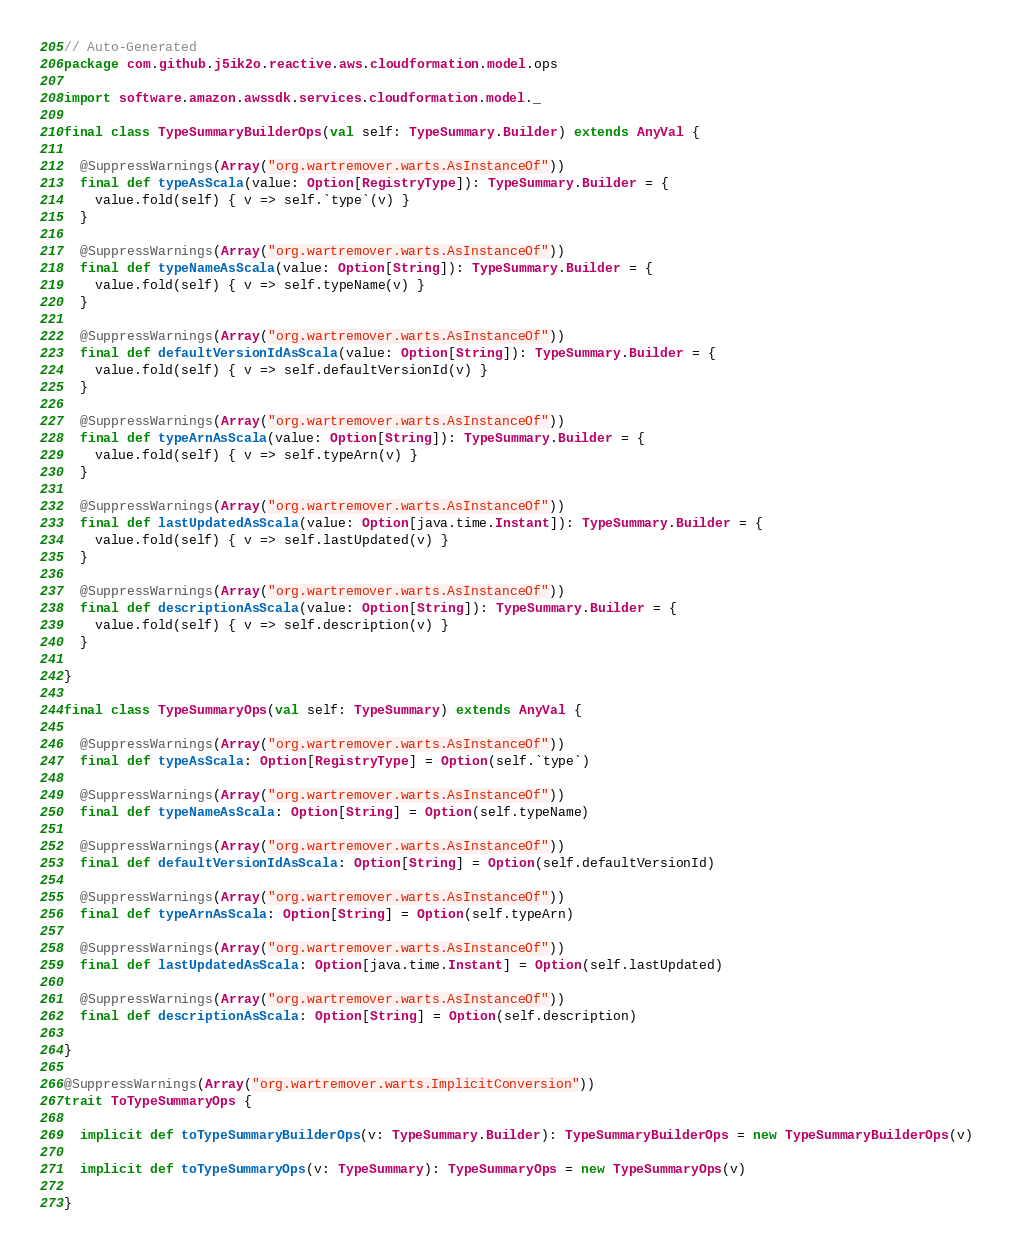Convert code to text. <code><loc_0><loc_0><loc_500><loc_500><_Scala_>// Auto-Generated
package com.github.j5ik2o.reactive.aws.cloudformation.model.ops

import software.amazon.awssdk.services.cloudformation.model._

final class TypeSummaryBuilderOps(val self: TypeSummary.Builder) extends AnyVal {

  @SuppressWarnings(Array("org.wartremover.warts.AsInstanceOf"))
  final def typeAsScala(value: Option[RegistryType]): TypeSummary.Builder = {
    value.fold(self) { v => self.`type`(v) }
  }

  @SuppressWarnings(Array("org.wartremover.warts.AsInstanceOf"))
  final def typeNameAsScala(value: Option[String]): TypeSummary.Builder = {
    value.fold(self) { v => self.typeName(v) }
  }

  @SuppressWarnings(Array("org.wartremover.warts.AsInstanceOf"))
  final def defaultVersionIdAsScala(value: Option[String]): TypeSummary.Builder = {
    value.fold(self) { v => self.defaultVersionId(v) }
  }

  @SuppressWarnings(Array("org.wartremover.warts.AsInstanceOf"))
  final def typeArnAsScala(value: Option[String]): TypeSummary.Builder = {
    value.fold(self) { v => self.typeArn(v) }
  }

  @SuppressWarnings(Array("org.wartremover.warts.AsInstanceOf"))
  final def lastUpdatedAsScala(value: Option[java.time.Instant]): TypeSummary.Builder = {
    value.fold(self) { v => self.lastUpdated(v) }
  }

  @SuppressWarnings(Array("org.wartremover.warts.AsInstanceOf"))
  final def descriptionAsScala(value: Option[String]): TypeSummary.Builder = {
    value.fold(self) { v => self.description(v) }
  }

}

final class TypeSummaryOps(val self: TypeSummary) extends AnyVal {

  @SuppressWarnings(Array("org.wartremover.warts.AsInstanceOf"))
  final def typeAsScala: Option[RegistryType] = Option(self.`type`)

  @SuppressWarnings(Array("org.wartremover.warts.AsInstanceOf"))
  final def typeNameAsScala: Option[String] = Option(self.typeName)

  @SuppressWarnings(Array("org.wartremover.warts.AsInstanceOf"))
  final def defaultVersionIdAsScala: Option[String] = Option(self.defaultVersionId)

  @SuppressWarnings(Array("org.wartremover.warts.AsInstanceOf"))
  final def typeArnAsScala: Option[String] = Option(self.typeArn)

  @SuppressWarnings(Array("org.wartremover.warts.AsInstanceOf"))
  final def lastUpdatedAsScala: Option[java.time.Instant] = Option(self.lastUpdated)

  @SuppressWarnings(Array("org.wartremover.warts.AsInstanceOf"))
  final def descriptionAsScala: Option[String] = Option(self.description)

}

@SuppressWarnings(Array("org.wartremover.warts.ImplicitConversion"))
trait ToTypeSummaryOps {

  implicit def toTypeSummaryBuilderOps(v: TypeSummary.Builder): TypeSummaryBuilderOps = new TypeSummaryBuilderOps(v)

  implicit def toTypeSummaryOps(v: TypeSummary): TypeSummaryOps = new TypeSummaryOps(v)

}
</code> 